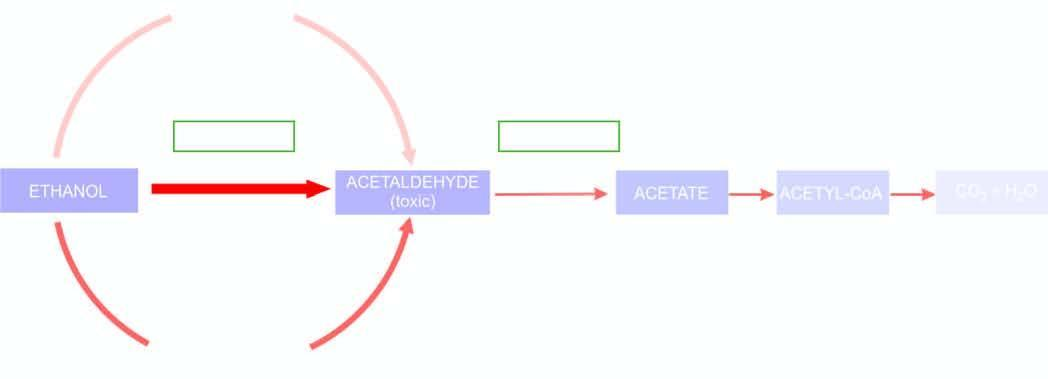what does thickness and intensity of colour of on left side of figure correspond to?
Answer the question using a single word or phrase. Extent of metabolic pathway 